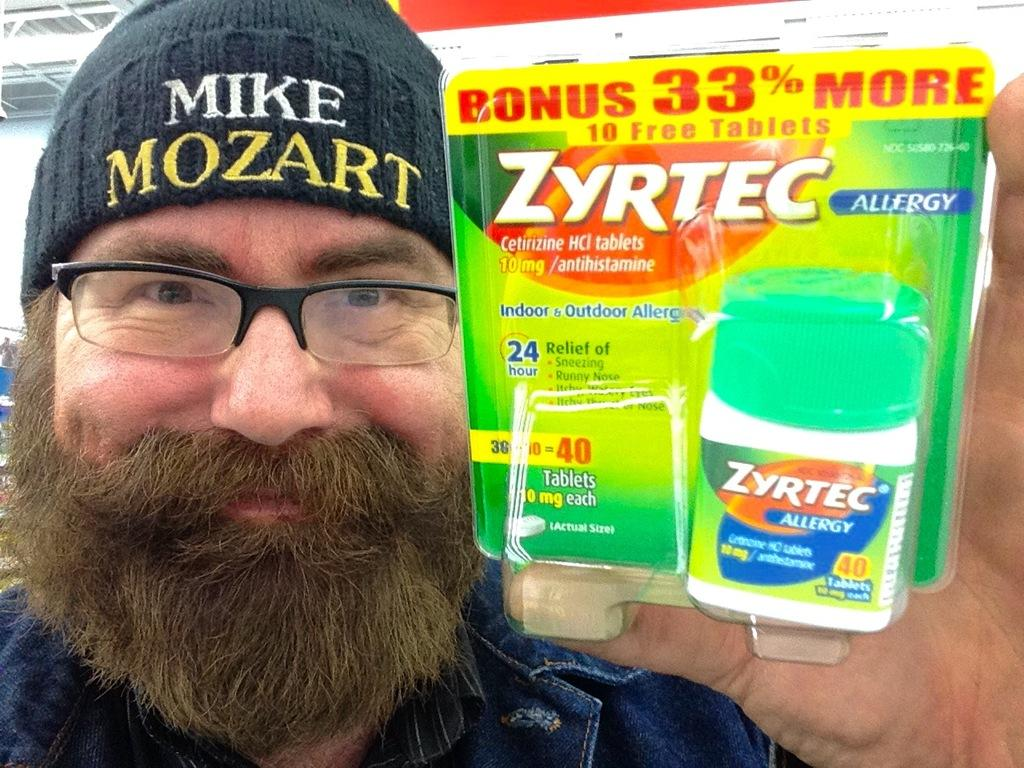Who is present in the image? There is a man in the image. What is the man holding in the image? The man is holding a medicine bottle. What accessories is the man wearing in the image? The man is wearing a cap and spectacles. What is the man's facial expression in the image? The man has a smile on his face. What can be seen in the background of the image? There is a building visible in the background of the image. What type of air can be seen coming out of the medicine bottle in the image? There is no air coming out of the medicine bottle in the image. How many copies of the man are present in the image? There is only one man present in the image. 